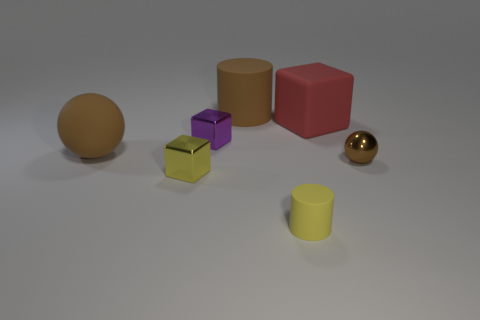Subtract all yellow cubes. How many cubes are left? 2 Add 3 large yellow things. How many objects exist? 10 Subtract all spheres. How many objects are left? 5 Subtract all purple cylinders. Subtract all red spheres. How many cylinders are left? 2 Subtract all tiny brown matte cylinders. Subtract all purple metallic things. How many objects are left? 6 Add 7 purple metallic objects. How many purple metallic objects are left? 8 Add 4 metal balls. How many metal balls exist? 5 Subtract 0 yellow balls. How many objects are left? 7 